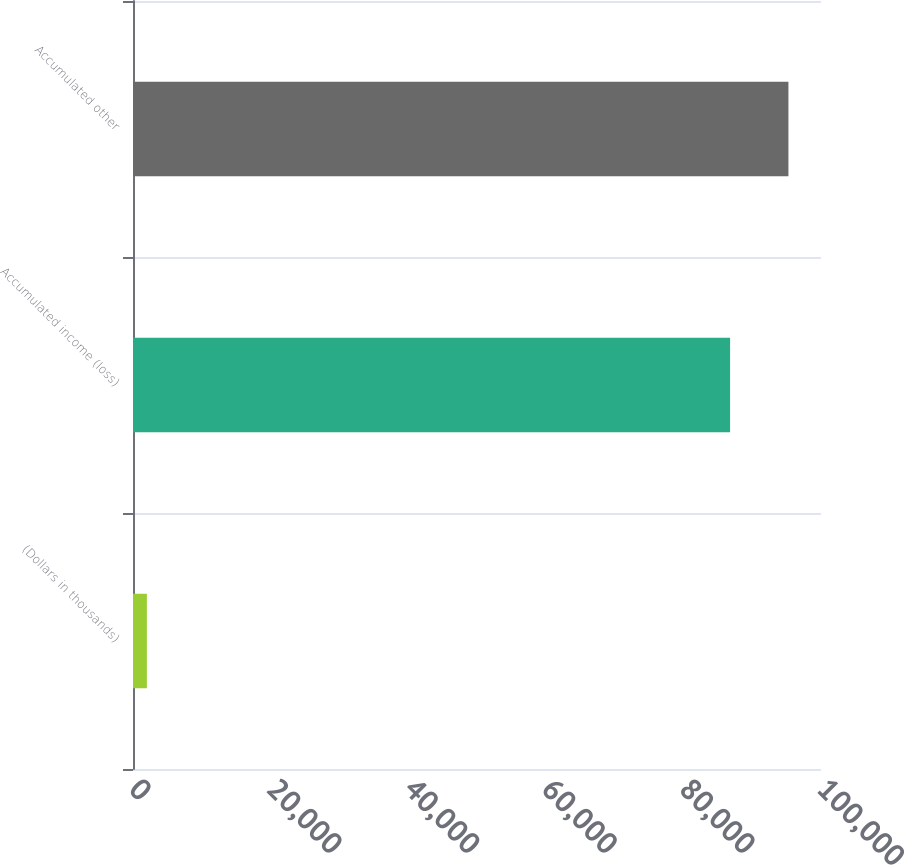<chart> <loc_0><loc_0><loc_500><loc_500><bar_chart><fcel>(Dollars in thousands)<fcel>Accumulated income (loss)<fcel>Accumulated other<nl><fcel>2017<fcel>86788<fcel>95265.1<nl></chart> 